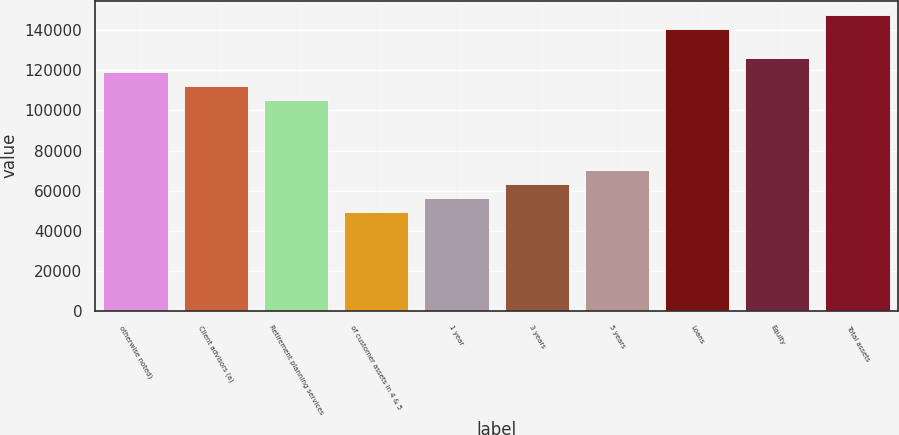Convert chart to OTSL. <chart><loc_0><loc_0><loc_500><loc_500><bar_chart><fcel>otherwise noted)<fcel>Client advisors (a)<fcel>Retirement planning services<fcel>of customer assets in 4 & 5<fcel>1 year<fcel>3 years<fcel>5 years<fcel>Loans<fcel>Equity<fcel>Total assets<nl><fcel>119304<fcel>112286<fcel>105269<fcel>49125.3<fcel>56143.2<fcel>63161.1<fcel>70179<fcel>140358<fcel>126322<fcel>147376<nl></chart> 